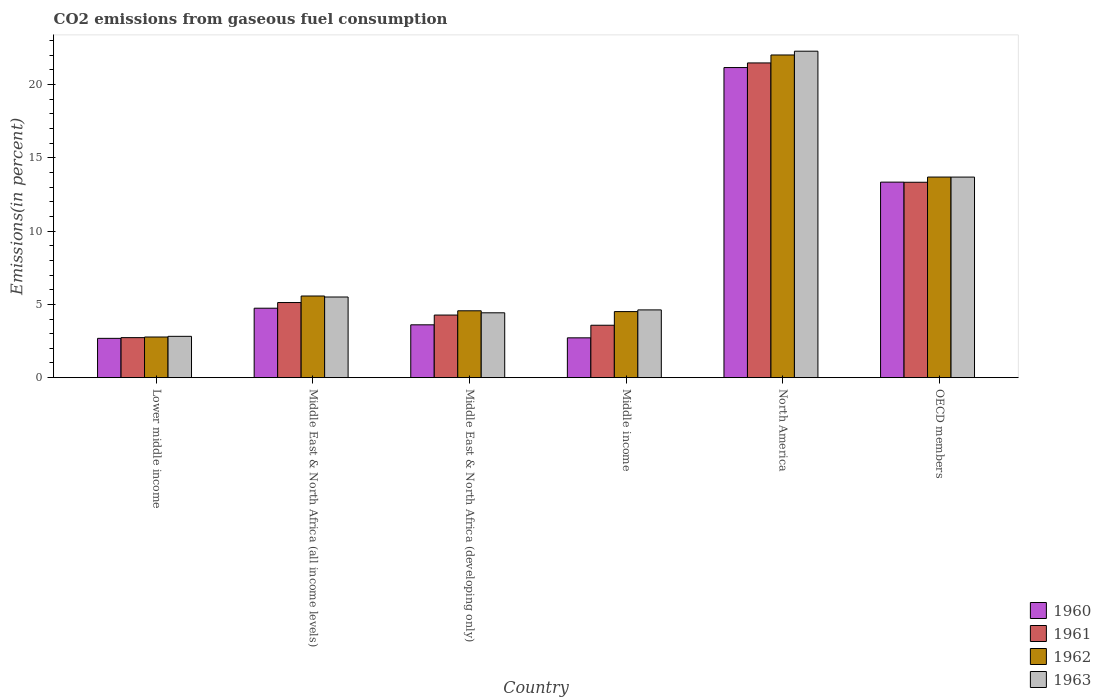How many different coloured bars are there?
Provide a short and direct response. 4. Are the number of bars per tick equal to the number of legend labels?
Your response must be concise. Yes. Are the number of bars on each tick of the X-axis equal?
Give a very brief answer. Yes. How many bars are there on the 5th tick from the left?
Your response must be concise. 4. How many bars are there on the 1st tick from the right?
Keep it short and to the point. 4. What is the total CO2 emitted in 1960 in Middle income?
Provide a succinct answer. 2.72. Across all countries, what is the maximum total CO2 emitted in 1963?
Ensure brevity in your answer.  22.26. Across all countries, what is the minimum total CO2 emitted in 1962?
Provide a short and direct response. 2.77. In which country was the total CO2 emitted in 1963 maximum?
Your response must be concise. North America. In which country was the total CO2 emitted in 1962 minimum?
Your answer should be compact. Lower middle income. What is the total total CO2 emitted in 1961 in the graph?
Keep it short and to the point. 50.48. What is the difference between the total CO2 emitted in 1963 in Middle East & North Africa (developing only) and that in Middle income?
Offer a very short reply. -0.2. What is the difference between the total CO2 emitted in 1961 in Middle East & North Africa (all income levels) and the total CO2 emitted in 1962 in Lower middle income?
Ensure brevity in your answer.  2.35. What is the average total CO2 emitted in 1962 per country?
Your answer should be compact. 8.85. What is the difference between the total CO2 emitted of/in 1960 and total CO2 emitted of/in 1961 in Middle income?
Your answer should be compact. -0.86. What is the ratio of the total CO2 emitted in 1960 in Middle East & North Africa (all income levels) to that in OECD members?
Give a very brief answer. 0.36. What is the difference between the highest and the second highest total CO2 emitted in 1960?
Your answer should be very brief. 8.6. What is the difference between the highest and the lowest total CO2 emitted in 1961?
Ensure brevity in your answer.  18.73. Is it the case that in every country, the sum of the total CO2 emitted in 1962 and total CO2 emitted in 1960 is greater than the total CO2 emitted in 1963?
Your response must be concise. Yes. Are all the bars in the graph horizontal?
Give a very brief answer. No. How many countries are there in the graph?
Keep it short and to the point. 6. Where does the legend appear in the graph?
Provide a succinct answer. Bottom right. How many legend labels are there?
Provide a short and direct response. 4. What is the title of the graph?
Your response must be concise. CO2 emissions from gaseous fuel consumption. What is the label or title of the Y-axis?
Make the answer very short. Emissions(in percent). What is the Emissions(in percent) of 1960 in Lower middle income?
Offer a very short reply. 2.68. What is the Emissions(in percent) in 1961 in Lower middle income?
Your answer should be compact. 2.73. What is the Emissions(in percent) in 1962 in Lower middle income?
Ensure brevity in your answer.  2.77. What is the Emissions(in percent) of 1963 in Lower middle income?
Offer a very short reply. 2.82. What is the Emissions(in percent) in 1960 in Middle East & North Africa (all income levels)?
Offer a very short reply. 4.74. What is the Emissions(in percent) in 1961 in Middle East & North Africa (all income levels)?
Provide a succinct answer. 5.12. What is the Emissions(in percent) of 1962 in Middle East & North Africa (all income levels)?
Your response must be concise. 5.57. What is the Emissions(in percent) in 1963 in Middle East & North Africa (all income levels)?
Offer a terse response. 5.5. What is the Emissions(in percent) in 1960 in Middle East & North Africa (developing only)?
Offer a very short reply. 3.6. What is the Emissions(in percent) in 1961 in Middle East & North Africa (developing only)?
Offer a terse response. 4.27. What is the Emissions(in percent) in 1962 in Middle East & North Africa (developing only)?
Offer a very short reply. 4.56. What is the Emissions(in percent) in 1963 in Middle East & North Africa (developing only)?
Offer a very short reply. 4.42. What is the Emissions(in percent) of 1960 in Middle income?
Provide a short and direct response. 2.72. What is the Emissions(in percent) of 1961 in Middle income?
Give a very brief answer. 3.57. What is the Emissions(in percent) in 1962 in Middle income?
Your response must be concise. 4.5. What is the Emissions(in percent) of 1963 in Middle income?
Offer a very short reply. 4.62. What is the Emissions(in percent) of 1960 in North America?
Give a very brief answer. 21.15. What is the Emissions(in percent) of 1961 in North America?
Your answer should be very brief. 21.46. What is the Emissions(in percent) of 1962 in North America?
Offer a very short reply. 22. What is the Emissions(in percent) of 1963 in North America?
Give a very brief answer. 22.26. What is the Emissions(in percent) of 1960 in OECD members?
Give a very brief answer. 13.33. What is the Emissions(in percent) in 1961 in OECD members?
Give a very brief answer. 13.33. What is the Emissions(in percent) in 1962 in OECD members?
Make the answer very short. 13.68. What is the Emissions(in percent) in 1963 in OECD members?
Your answer should be compact. 13.68. Across all countries, what is the maximum Emissions(in percent) of 1960?
Your answer should be very brief. 21.15. Across all countries, what is the maximum Emissions(in percent) of 1961?
Ensure brevity in your answer.  21.46. Across all countries, what is the maximum Emissions(in percent) of 1962?
Ensure brevity in your answer.  22. Across all countries, what is the maximum Emissions(in percent) in 1963?
Provide a succinct answer. 22.26. Across all countries, what is the minimum Emissions(in percent) of 1960?
Ensure brevity in your answer.  2.68. Across all countries, what is the minimum Emissions(in percent) in 1961?
Offer a very short reply. 2.73. Across all countries, what is the minimum Emissions(in percent) in 1962?
Provide a short and direct response. 2.77. Across all countries, what is the minimum Emissions(in percent) of 1963?
Make the answer very short. 2.82. What is the total Emissions(in percent) of 1960 in the graph?
Ensure brevity in your answer.  48.22. What is the total Emissions(in percent) in 1961 in the graph?
Give a very brief answer. 50.48. What is the total Emissions(in percent) of 1962 in the graph?
Give a very brief answer. 53.09. What is the total Emissions(in percent) in 1963 in the graph?
Keep it short and to the point. 53.3. What is the difference between the Emissions(in percent) in 1960 in Lower middle income and that in Middle East & North Africa (all income levels)?
Keep it short and to the point. -2.06. What is the difference between the Emissions(in percent) of 1961 in Lower middle income and that in Middle East & North Africa (all income levels)?
Offer a terse response. -2.39. What is the difference between the Emissions(in percent) in 1962 in Lower middle income and that in Middle East & North Africa (all income levels)?
Offer a terse response. -2.8. What is the difference between the Emissions(in percent) of 1963 in Lower middle income and that in Middle East & North Africa (all income levels)?
Make the answer very short. -2.68. What is the difference between the Emissions(in percent) of 1960 in Lower middle income and that in Middle East & North Africa (developing only)?
Make the answer very short. -0.92. What is the difference between the Emissions(in percent) of 1961 in Lower middle income and that in Middle East & North Africa (developing only)?
Make the answer very short. -1.54. What is the difference between the Emissions(in percent) of 1962 in Lower middle income and that in Middle East & North Africa (developing only)?
Provide a short and direct response. -1.79. What is the difference between the Emissions(in percent) in 1963 in Lower middle income and that in Middle East & North Africa (developing only)?
Give a very brief answer. -1.6. What is the difference between the Emissions(in percent) in 1960 in Lower middle income and that in Middle income?
Provide a short and direct response. -0.03. What is the difference between the Emissions(in percent) in 1961 in Lower middle income and that in Middle income?
Provide a short and direct response. -0.84. What is the difference between the Emissions(in percent) of 1962 in Lower middle income and that in Middle income?
Provide a short and direct response. -1.73. What is the difference between the Emissions(in percent) of 1963 in Lower middle income and that in Middle income?
Provide a succinct answer. -1.8. What is the difference between the Emissions(in percent) of 1960 in Lower middle income and that in North America?
Make the answer very short. -18.47. What is the difference between the Emissions(in percent) of 1961 in Lower middle income and that in North America?
Ensure brevity in your answer.  -18.73. What is the difference between the Emissions(in percent) of 1962 in Lower middle income and that in North America?
Offer a terse response. -19.23. What is the difference between the Emissions(in percent) of 1963 in Lower middle income and that in North America?
Provide a succinct answer. -19.44. What is the difference between the Emissions(in percent) in 1960 in Lower middle income and that in OECD members?
Your answer should be compact. -10.65. What is the difference between the Emissions(in percent) of 1961 in Lower middle income and that in OECD members?
Ensure brevity in your answer.  -10.6. What is the difference between the Emissions(in percent) of 1962 in Lower middle income and that in OECD members?
Offer a very short reply. -10.91. What is the difference between the Emissions(in percent) in 1963 in Lower middle income and that in OECD members?
Offer a terse response. -10.86. What is the difference between the Emissions(in percent) of 1960 in Middle East & North Africa (all income levels) and that in Middle East & North Africa (developing only)?
Provide a short and direct response. 1.13. What is the difference between the Emissions(in percent) in 1961 in Middle East & North Africa (all income levels) and that in Middle East & North Africa (developing only)?
Your answer should be compact. 0.85. What is the difference between the Emissions(in percent) in 1962 in Middle East & North Africa (all income levels) and that in Middle East & North Africa (developing only)?
Your answer should be compact. 1.01. What is the difference between the Emissions(in percent) of 1963 in Middle East & North Africa (all income levels) and that in Middle East & North Africa (developing only)?
Ensure brevity in your answer.  1.08. What is the difference between the Emissions(in percent) of 1960 in Middle East & North Africa (all income levels) and that in Middle income?
Offer a terse response. 2.02. What is the difference between the Emissions(in percent) of 1961 in Middle East & North Africa (all income levels) and that in Middle income?
Your response must be concise. 1.55. What is the difference between the Emissions(in percent) in 1962 in Middle East & North Africa (all income levels) and that in Middle income?
Provide a short and direct response. 1.06. What is the difference between the Emissions(in percent) of 1963 in Middle East & North Africa (all income levels) and that in Middle income?
Keep it short and to the point. 0.88. What is the difference between the Emissions(in percent) of 1960 in Middle East & North Africa (all income levels) and that in North America?
Offer a terse response. -16.41. What is the difference between the Emissions(in percent) in 1961 in Middle East & North Africa (all income levels) and that in North America?
Your response must be concise. -16.34. What is the difference between the Emissions(in percent) of 1962 in Middle East & North Africa (all income levels) and that in North America?
Offer a very short reply. -16.44. What is the difference between the Emissions(in percent) in 1963 in Middle East & North Africa (all income levels) and that in North America?
Make the answer very short. -16.76. What is the difference between the Emissions(in percent) in 1960 in Middle East & North Africa (all income levels) and that in OECD members?
Make the answer very short. -8.6. What is the difference between the Emissions(in percent) in 1961 in Middle East & North Africa (all income levels) and that in OECD members?
Give a very brief answer. -8.2. What is the difference between the Emissions(in percent) of 1962 in Middle East & North Africa (all income levels) and that in OECD members?
Keep it short and to the point. -8.11. What is the difference between the Emissions(in percent) in 1963 in Middle East & North Africa (all income levels) and that in OECD members?
Make the answer very short. -8.18. What is the difference between the Emissions(in percent) in 1960 in Middle East & North Africa (developing only) and that in Middle income?
Your answer should be very brief. 0.89. What is the difference between the Emissions(in percent) in 1961 in Middle East & North Africa (developing only) and that in Middle income?
Your response must be concise. 0.7. What is the difference between the Emissions(in percent) of 1962 in Middle East & North Africa (developing only) and that in Middle income?
Keep it short and to the point. 0.06. What is the difference between the Emissions(in percent) of 1963 in Middle East & North Africa (developing only) and that in Middle income?
Offer a terse response. -0.2. What is the difference between the Emissions(in percent) of 1960 in Middle East & North Africa (developing only) and that in North America?
Your answer should be very brief. -17.54. What is the difference between the Emissions(in percent) of 1961 in Middle East & North Africa (developing only) and that in North America?
Your response must be concise. -17.19. What is the difference between the Emissions(in percent) in 1962 in Middle East & North Africa (developing only) and that in North America?
Your answer should be very brief. -17.44. What is the difference between the Emissions(in percent) of 1963 in Middle East & North Africa (developing only) and that in North America?
Give a very brief answer. -17.84. What is the difference between the Emissions(in percent) of 1960 in Middle East & North Africa (developing only) and that in OECD members?
Provide a succinct answer. -9.73. What is the difference between the Emissions(in percent) in 1961 in Middle East & North Africa (developing only) and that in OECD members?
Provide a short and direct response. -9.06. What is the difference between the Emissions(in percent) of 1962 in Middle East & North Africa (developing only) and that in OECD members?
Provide a succinct answer. -9.12. What is the difference between the Emissions(in percent) in 1963 in Middle East & North Africa (developing only) and that in OECD members?
Offer a very short reply. -9.25. What is the difference between the Emissions(in percent) of 1960 in Middle income and that in North America?
Your answer should be very brief. -18.43. What is the difference between the Emissions(in percent) in 1961 in Middle income and that in North America?
Offer a terse response. -17.89. What is the difference between the Emissions(in percent) in 1962 in Middle income and that in North America?
Make the answer very short. -17.5. What is the difference between the Emissions(in percent) in 1963 in Middle income and that in North America?
Provide a succinct answer. -17.64. What is the difference between the Emissions(in percent) of 1960 in Middle income and that in OECD members?
Your answer should be compact. -10.62. What is the difference between the Emissions(in percent) in 1961 in Middle income and that in OECD members?
Provide a short and direct response. -9.75. What is the difference between the Emissions(in percent) of 1962 in Middle income and that in OECD members?
Offer a terse response. -9.17. What is the difference between the Emissions(in percent) in 1963 in Middle income and that in OECD members?
Make the answer very short. -9.06. What is the difference between the Emissions(in percent) in 1960 in North America and that in OECD members?
Offer a terse response. 7.81. What is the difference between the Emissions(in percent) of 1961 in North America and that in OECD members?
Your answer should be very brief. 8.14. What is the difference between the Emissions(in percent) in 1962 in North America and that in OECD members?
Your answer should be compact. 8.32. What is the difference between the Emissions(in percent) of 1963 in North America and that in OECD members?
Provide a short and direct response. 8.58. What is the difference between the Emissions(in percent) of 1960 in Lower middle income and the Emissions(in percent) of 1961 in Middle East & North Africa (all income levels)?
Provide a succinct answer. -2.44. What is the difference between the Emissions(in percent) of 1960 in Lower middle income and the Emissions(in percent) of 1962 in Middle East & North Africa (all income levels)?
Make the answer very short. -2.89. What is the difference between the Emissions(in percent) of 1960 in Lower middle income and the Emissions(in percent) of 1963 in Middle East & North Africa (all income levels)?
Keep it short and to the point. -2.82. What is the difference between the Emissions(in percent) of 1961 in Lower middle income and the Emissions(in percent) of 1962 in Middle East & North Africa (all income levels)?
Ensure brevity in your answer.  -2.84. What is the difference between the Emissions(in percent) in 1961 in Lower middle income and the Emissions(in percent) in 1963 in Middle East & North Africa (all income levels)?
Offer a very short reply. -2.77. What is the difference between the Emissions(in percent) in 1962 in Lower middle income and the Emissions(in percent) in 1963 in Middle East & North Africa (all income levels)?
Make the answer very short. -2.73. What is the difference between the Emissions(in percent) of 1960 in Lower middle income and the Emissions(in percent) of 1961 in Middle East & North Africa (developing only)?
Your answer should be compact. -1.59. What is the difference between the Emissions(in percent) of 1960 in Lower middle income and the Emissions(in percent) of 1962 in Middle East & North Africa (developing only)?
Provide a succinct answer. -1.88. What is the difference between the Emissions(in percent) in 1960 in Lower middle income and the Emissions(in percent) in 1963 in Middle East & North Africa (developing only)?
Offer a very short reply. -1.74. What is the difference between the Emissions(in percent) of 1961 in Lower middle income and the Emissions(in percent) of 1962 in Middle East & North Africa (developing only)?
Keep it short and to the point. -1.83. What is the difference between the Emissions(in percent) of 1961 in Lower middle income and the Emissions(in percent) of 1963 in Middle East & North Africa (developing only)?
Keep it short and to the point. -1.69. What is the difference between the Emissions(in percent) in 1962 in Lower middle income and the Emissions(in percent) in 1963 in Middle East & North Africa (developing only)?
Give a very brief answer. -1.65. What is the difference between the Emissions(in percent) of 1960 in Lower middle income and the Emissions(in percent) of 1961 in Middle income?
Offer a terse response. -0.89. What is the difference between the Emissions(in percent) in 1960 in Lower middle income and the Emissions(in percent) in 1962 in Middle income?
Offer a terse response. -1.82. What is the difference between the Emissions(in percent) of 1960 in Lower middle income and the Emissions(in percent) of 1963 in Middle income?
Offer a terse response. -1.94. What is the difference between the Emissions(in percent) of 1961 in Lower middle income and the Emissions(in percent) of 1962 in Middle income?
Offer a very short reply. -1.78. What is the difference between the Emissions(in percent) in 1961 in Lower middle income and the Emissions(in percent) in 1963 in Middle income?
Provide a succinct answer. -1.89. What is the difference between the Emissions(in percent) in 1962 in Lower middle income and the Emissions(in percent) in 1963 in Middle income?
Your response must be concise. -1.85. What is the difference between the Emissions(in percent) of 1960 in Lower middle income and the Emissions(in percent) of 1961 in North America?
Make the answer very short. -18.78. What is the difference between the Emissions(in percent) in 1960 in Lower middle income and the Emissions(in percent) in 1962 in North America?
Make the answer very short. -19.32. What is the difference between the Emissions(in percent) in 1960 in Lower middle income and the Emissions(in percent) in 1963 in North America?
Provide a succinct answer. -19.58. What is the difference between the Emissions(in percent) of 1961 in Lower middle income and the Emissions(in percent) of 1962 in North America?
Provide a short and direct response. -19.27. What is the difference between the Emissions(in percent) of 1961 in Lower middle income and the Emissions(in percent) of 1963 in North America?
Your response must be concise. -19.53. What is the difference between the Emissions(in percent) of 1962 in Lower middle income and the Emissions(in percent) of 1963 in North America?
Give a very brief answer. -19.49. What is the difference between the Emissions(in percent) of 1960 in Lower middle income and the Emissions(in percent) of 1961 in OECD members?
Make the answer very short. -10.64. What is the difference between the Emissions(in percent) of 1960 in Lower middle income and the Emissions(in percent) of 1962 in OECD members?
Provide a succinct answer. -11. What is the difference between the Emissions(in percent) of 1960 in Lower middle income and the Emissions(in percent) of 1963 in OECD members?
Give a very brief answer. -11. What is the difference between the Emissions(in percent) of 1961 in Lower middle income and the Emissions(in percent) of 1962 in OECD members?
Provide a short and direct response. -10.95. What is the difference between the Emissions(in percent) of 1961 in Lower middle income and the Emissions(in percent) of 1963 in OECD members?
Ensure brevity in your answer.  -10.95. What is the difference between the Emissions(in percent) in 1962 in Lower middle income and the Emissions(in percent) in 1963 in OECD members?
Provide a succinct answer. -10.91. What is the difference between the Emissions(in percent) of 1960 in Middle East & North Africa (all income levels) and the Emissions(in percent) of 1961 in Middle East & North Africa (developing only)?
Your answer should be very brief. 0.47. What is the difference between the Emissions(in percent) of 1960 in Middle East & North Africa (all income levels) and the Emissions(in percent) of 1962 in Middle East & North Africa (developing only)?
Your answer should be compact. 0.18. What is the difference between the Emissions(in percent) of 1960 in Middle East & North Africa (all income levels) and the Emissions(in percent) of 1963 in Middle East & North Africa (developing only)?
Make the answer very short. 0.31. What is the difference between the Emissions(in percent) of 1961 in Middle East & North Africa (all income levels) and the Emissions(in percent) of 1962 in Middle East & North Africa (developing only)?
Offer a very short reply. 0.56. What is the difference between the Emissions(in percent) of 1961 in Middle East & North Africa (all income levels) and the Emissions(in percent) of 1963 in Middle East & North Africa (developing only)?
Make the answer very short. 0.7. What is the difference between the Emissions(in percent) of 1962 in Middle East & North Africa (all income levels) and the Emissions(in percent) of 1963 in Middle East & North Africa (developing only)?
Provide a succinct answer. 1.15. What is the difference between the Emissions(in percent) of 1960 in Middle East & North Africa (all income levels) and the Emissions(in percent) of 1961 in Middle income?
Your answer should be very brief. 1.16. What is the difference between the Emissions(in percent) in 1960 in Middle East & North Africa (all income levels) and the Emissions(in percent) in 1962 in Middle income?
Ensure brevity in your answer.  0.23. What is the difference between the Emissions(in percent) of 1960 in Middle East & North Africa (all income levels) and the Emissions(in percent) of 1963 in Middle income?
Your response must be concise. 0.12. What is the difference between the Emissions(in percent) of 1961 in Middle East & North Africa (all income levels) and the Emissions(in percent) of 1962 in Middle income?
Provide a succinct answer. 0.62. What is the difference between the Emissions(in percent) of 1961 in Middle East & North Africa (all income levels) and the Emissions(in percent) of 1963 in Middle income?
Your answer should be very brief. 0.5. What is the difference between the Emissions(in percent) of 1962 in Middle East & North Africa (all income levels) and the Emissions(in percent) of 1963 in Middle income?
Provide a short and direct response. 0.95. What is the difference between the Emissions(in percent) of 1960 in Middle East & North Africa (all income levels) and the Emissions(in percent) of 1961 in North America?
Provide a succinct answer. -16.73. What is the difference between the Emissions(in percent) of 1960 in Middle East & North Africa (all income levels) and the Emissions(in percent) of 1962 in North America?
Ensure brevity in your answer.  -17.27. What is the difference between the Emissions(in percent) of 1960 in Middle East & North Africa (all income levels) and the Emissions(in percent) of 1963 in North America?
Ensure brevity in your answer.  -17.53. What is the difference between the Emissions(in percent) in 1961 in Middle East & North Africa (all income levels) and the Emissions(in percent) in 1962 in North America?
Your answer should be very brief. -16.88. What is the difference between the Emissions(in percent) of 1961 in Middle East & North Africa (all income levels) and the Emissions(in percent) of 1963 in North America?
Give a very brief answer. -17.14. What is the difference between the Emissions(in percent) of 1962 in Middle East & North Africa (all income levels) and the Emissions(in percent) of 1963 in North America?
Give a very brief answer. -16.69. What is the difference between the Emissions(in percent) in 1960 in Middle East & North Africa (all income levels) and the Emissions(in percent) in 1961 in OECD members?
Ensure brevity in your answer.  -8.59. What is the difference between the Emissions(in percent) in 1960 in Middle East & North Africa (all income levels) and the Emissions(in percent) in 1962 in OECD members?
Make the answer very short. -8.94. What is the difference between the Emissions(in percent) in 1960 in Middle East & North Africa (all income levels) and the Emissions(in percent) in 1963 in OECD members?
Your response must be concise. -8.94. What is the difference between the Emissions(in percent) of 1961 in Middle East & North Africa (all income levels) and the Emissions(in percent) of 1962 in OECD members?
Provide a short and direct response. -8.56. What is the difference between the Emissions(in percent) of 1961 in Middle East & North Africa (all income levels) and the Emissions(in percent) of 1963 in OECD members?
Offer a terse response. -8.55. What is the difference between the Emissions(in percent) in 1962 in Middle East & North Africa (all income levels) and the Emissions(in percent) in 1963 in OECD members?
Make the answer very short. -8.11. What is the difference between the Emissions(in percent) of 1960 in Middle East & North Africa (developing only) and the Emissions(in percent) of 1961 in Middle income?
Your response must be concise. 0.03. What is the difference between the Emissions(in percent) of 1960 in Middle East & North Africa (developing only) and the Emissions(in percent) of 1962 in Middle income?
Your answer should be compact. -0.9. What is the difference between the Emissions(in percent) in 1960 in Middle East & North Africa (developing only) and the Emissions(in percent) in 1963 in Middle income?
Offer a terse response. -1.02. What is the difference between the Emissions(in percent) in 1961 in Middle East & North Africa (developing only) and the Emissions(in percent) in 1962 in Middle income?
Offer a very short reply. -0.24. What is the difference between the Emissions(in percent) of 1961 in Middle East & North Africa (developing only) and the Emissions(in percent) of 1963 in Middle income?
Keep it short and to the point. -0.35. What is the difference between the Emissions(in percent) of 1962 in Middle East & North Africa (developing only) and the Emissions(in percent) of 1963 in Middle income?
Make the answer very short. -0.06. What is the difference between the Emissions(in percent) in 1960 in Middle East & North Africa (developing only) and the Emissions(in percent) in 1961 in North America?
Keep it short and to the point. -17.86. What is the difference between the Emissions(in percent) of 1960 in Middle East & North Africa (developing only) and the Emissions(in percent) of 1962 in North America?
Your answer should be compact. -18.4. What is the difference between the Emissions(in percent) in 1960 in Middle East & North Africa (developing only) and the Emissions(in percent) in 1963 in North America?
Provide a succinct answer. -18.66. What is the difference between the Emissions(in percent) in 1961 in Middle East & North Africa (developing only) and the Emissions(in percent) in 1962 in North America?
Make the answer very short. -17.73. What is the difference between the Emissions(in percent) of 1961 in Middle East & North Africa (developing only) and the Emissions(in percent) of 1963 in North America?
Your response must be concise. -17.99. What is the difference between the Emissions(in percent) of 1962 in Middle East & North Africa (developing only) and the Emissions(in percent) of 1963 in North America?
Provide a short and direct response. -17.7. What is the difference between the Emissions(in percent) in 1960 in Middle East & North Africa (developing only) and the Emissions(in percent) in 1961 in OECD members?
Ensure brevity in your answer.  -9.72. What is the difference between the Emissions(in percent) of 1960 in Middle East & North Africa (developing only) and the Emissions(in percent) of 1962 in OECD members?
Provide a short and direct response. -10.08. What is the difference between the Emissions(in percent) of 1960 in Middle East & North Africa (developing only) and the Emissions(in percent) of 1963 in OECD members?
Keep it short and to the point. -10.07. What is the difference between the Emissions(in percent) of 1961 in Middle East & North Africa (developing only) and the Emissions(in percent) of 1962 in OECD members?
Provide a short and direct response. -9.41. What is the difference between the Emissions(in percent) of 1961 in Middle East & North Africa (developing only) and the Emissions(in percent) of 1963 in OECD members?
Provide a succinct answer. -9.41. What is the difference between the Emissions(in percent) of 1962 in Middle East & North Africa (developing only) and the Emissions(in percent) of 1963 in OECD members?
Keep it short and to the point. -9.12. What is the difference between the Emissions(in percent) in 1960 in Middle income and the Emissions(in percent) in 1961 in North America?
Keep it short and to the point. -18.75. What is the difference between the Emissions(in percent) of 1960 in Middle income and the Emissions(in percent) of 1962 in North America?
Ensure brevity in your answer.  -19.29. What is the difference between the Emissions(in percent) in 1960 in Middle income and the Emissions(in percent) in 1963 in North America?
Offer a very short reply. -19.55. What is the difference between the Emissions(in percent) of 1961 in Middle income and the Emissions(in percent) of 1962 in North America?
Keep it short and to the point. -18.43. What is the difference between the Emissions(in percent) in 1961 in Middle income and the Emissions(in percent) in 1963 in North America?
Provide a short and direct response. -18.69. What is the difference between the Emissions(in percent) in 1962 in Middle income and the Emissions(in percent) in 1963 in North America?
Your answer should be very brief. -17.76. What is the difference between the Emissions(in percent) in 1960 in Middle income and the Emissions(in percent) in 1961 in OECD members?
Your response must be concise. -10.61. What is the difference between the Emissions(in percent) of 1960 in Middle income and the Emissions(in percent) of 1962 in OECD members?
Provide a succinct answer. -10.96. What is the difference between the Emissions(in percent) in 1960 in Middle income and the Emissions(in percent) in 1963 in OECD members?
Offer a terse response. -10.96. What is the difference between the Emissions(in percent) of 1961 in Middle income and the Emissions(in percent) of 1962 in OECD members?
Provide a short and direct response. -10.11. What is the difference between the Emissions(in percent) in 1961 in Middle income and the Emissions(in percent) in 1963 in OECD members?
Your answer should be very brief. -10.1. What is the difference between the Emissions(in percent) of 1962 in Middle income and the Emissions(in percent) of 1963 in OECD members?
Offer a very short reply. -9.17. What is the difference between the Emissions(in percent) of 1960 in North America and the Emissions(in percent) of 1961 in OECD members?
Offer a terse response. 7.82. What is the difference between the Emissions(in percent) in 1960 in North America and the Emissions(in percent) in 1962 in OECD members?
Provide a succinct answer. 7.47. What is the difference between the Emissions(in percent) of 1960 in North America and the Emissions(in percent) of 1963 in OECD members?
Ensure brevity in your answer.  7.47. What is the difference between the Emissions(in percent) in 1961 in North America and the Emissions(in percent) in 1962 in OECD members?
Give a very brief answer. 7.78. What is the difference between the Emissions(in percent) in 1961 in North America and the Emissions(in percent) in 1963 in OECD members?
Your answer should be very brief. 7.78. What is the difference between the Emissions(in percent) of 1962 in North America and the Emissions(in percent) of 1963 in OECD members?
Offer a terse response. 8.33. What is the average Emissions(in percent) in 1960 per country?
Give a very brief answer. 8.04. What is the average Emissions(in percent) of 1961 per country?
Provide a succinct answer. 8.41. What is the average Emissions(in percent) of 1962 per country?
Keep it short and to the point. 8.85. What is the average Emissions(in percent) of 1963 per country?
Your answer should be very brief. 8.88. What is the difference between the Emissions(in percent) of 1960 and Emissions(in percent) of 1961 in Lower middle income?
Offer a terse response. -0.05. What is the difference between the Emissions(in percent) of 1960 and Emissions(in percent) of 1962 in Lower middle income?
Your answer should be very brief. -0.09. What is the difference between the Emissions(in percent) of 1960 and Emissions(in percent) of 1963 in Lower middle income?
Provide a short and direct response. -0.14. What is the difference between the Emissions(in percent) of 1961 and Emissions(in percent) of 1962 in Lower middle income?
Offer a very short reply. -0.04. What is the difference between the Emissions(in percent) in 1961 and Emissions(in percent) in 1963 in Lower middle income?
Your answer should be very brief. -0.09. What is the difference between the Emissions(in percent) in 1962 and Emissions(in percent) in 1963 in Lower middle income?
Your answer should be compact. -0.05. What is the difference between the Emissions(in percent) in 1960 and Emissions(in percent) in 1961 in Middle East & North Africa (all income levels)?
Offer a very short reply. -0.39. What is the difference between the Emissions(in percent) in 1960 and Emissions(in percent) in 1962 in Middle East & North Africa (all income levels)?
Make the answer very short. -0.83. What is the difference between the Emissions(in percent) in 1960 and Emissions(in percent) in 1963 in Middle East & North Africa (all income levels)?
Your answer should be very brief. -0.76. What is the difference between the Emissions(in percent) in 1961 and Emissions(in percent) in 1962 in Middle East & North Africa (all income levels)?
Make the answer very short. -0.45. What is the difference between the Emissions(in percent) of 1961 and Emissions(in percent) of 1963 in Middle East & North Africa (all income levels)?
Keep it short and to the point. -0.38. What is the difference between the Emissions(in percent) of 1962 and Emissions(in percent) of 1963 in Middle East & North Africa (all income levels)?
Give a very brief answer. 0.07. What is the difference between the Emissions(in percent) of 1960 and Emissions(in percent) of 1961 in Middle East & North Africa (developing only)?
Keep it short and to the point. -0.67. What is the difference between the Emissions(in percent) in 1960 and Emissions(in percent) in 1962 in Middle East & North Africa (developing only)?
Ensure brevity in your answer.  -0.96. What is the difference between the Emissions(in percent) of 1960 and Emissions(in percent) of 1963 in Middle East & North Africa (developing only)?
Ensure brevity in your answer.  -0.82. What is the difference between the Emissions(in percent) in 1961 and Emissions(in percent) in 1962 in Middle East & North Africa (developing only)?
Provide a succinct answer. -0.29. What is the difference between the Emissions(in percent) in 1961 and Emissions(in percent) in 1963 in Middle East & North Africa (developing only)?
Offer a terse response. -0.15. What is the difference between the Emissions(in percent) in 1962 and Emissions(in percent) in 1963 in Middle East & North Africa (developing only)?
Give a very brief answer. 0.14. What is the difference between the Emissions(in percent) of 1960 and Emissions(in percent) of 1961 in Middle income?
Provide a succinct answer. -0.86. What is the difference between the Emissions(in percent) in 1960 and Emissions(in percent) in 1962 in Middle income?
Your response must be concise. -1.79. What is the difference between the Emissions(in percent) of 1960 and Emissions(in percent) of 1963 in Middle income?
Give a very brief answer. -1.91. What is the difference between the Emissions(in percent) in 1961 and Emissions(in percent) in 1962 in Middle income?
Ensure brevity in your answer.  -0.93. What is the difference between the Emissions(in percent) of 1961 and Emissions(in percent) of 1963 in Middle income?
Provide a short and direct response. -1.05. What is the difference between the Emissions(in percent) in 1962 and Emissions(in percent) in 1963 in Middle income?
Offer a very short reply. -0.12. What is the difference between the Emissions(in percent) of 1960 and Emissions(in percent) of 1961 in North America?
Provide a short and direct response. -0.32. What is the difference between the Emissions(in percent) in 1960 and Emissions(in percent) in 1962 in North America?
Your response must be concise. -0.86. What is the difference between the Emissions(in percent) in 1960 and Emissions(in percent) in 1963 in North America?
Keep it short and to the point. -1.12. What is the difference between the Emissions(in percent) of 1961 and Emissions(in percent) of 1962 in North America?
Your answer should be very brief. -0.54. What is the difference between the Emissions(in percent) of 1962 and Emissions(in percent) of 1963 in North America?
Provide a short and direct response. -0.26. What is the difference between the Emissions(in percent) in 1960 and Emissions(in percent) in 1961 in OECD members?
Provide a succinct answer. 0.01. What is the difference between the Emissions(in percent) of 1960 and Emissions(in percent) of 1962 in OECD members?
Your answer should be very brief. -0.35. What is the difference between the Emissions(in percent) of 1960 and Emissions(in percent) of 1963 in OECD members?
Your answer should be very brief. -0.34. What is the difference between the Emissions(in percent) of 1961 and Emissions(in percent) of 1962 in OECD members?
Make the answer very short. -0.35. What is the difference between the Emissions(in percent) in 1961 and Emissions(in percent) in 1963 in OECD members?
Provide a short and direct response. -0.35. What is the difference between the Emissions(in percent) in 1962 and Emissions(in percent) in 1963 in OECD members?
Your answer should be very brief. 0. What is the ratio of the Emissions(in percent) in 1960 in Lower middle income to that in Middle East & North Africa (all income levels)?
Offer a very short reply. 0.57. What is the ratio of the Emissions(in percent) of 1961 in Lower middle income to that in Middle East & North Africa (all income levels)?
Offer a terse response. 0.53. What is the ratio of the Emissions(in percent) of 1962 in Lower middle income to that in Middle East & North Africa (all income levels)?
Offer a terse response. 0.5. What is the ratio of the Emissions(in percent) in 1963 in Lower middle income to that in Middle East & North Africa (all income levels)?
Provide a short and direct response. 0.51. What is the ratio of the Emissions(in percent) of 1960 in Lower middle income to that in Middle East & North Africa (developing only)?
Offer a very short reply. 0.74. What is the ratio of the Emissions(in percent) of 1961 in Lower middle income to that in Middle East & North Africa (developing only)?
Offer a very short reply. 0.64. What is the ratio of the Emissions(in percent) of 1962 in Lower middle income to that in Middle East & North Africa (developing only)?
Your answer should be compact. 0.61. What is the ratio of the Emissions(in percent) of 1963 in Lower middle income to that in Middle East & North Africa (developing only)?
Make the answer very short. 0.64. What is the ratio of the Emissions(in percent) in 1960 in Lower middle income to that in Middle income?
Give a very brief answer. 0.99. What is the ratio of the Emissions(in percent) in 1961 in Lower middle income to that in Middle income?
Ensure brevity in your answer.  0.76. What is the ratio of the Emissions(in percent) in 1962 in Lower middle income to that in Middle income?
Provide a short and direct response. 0.62. What is the ratio of the Emissions(in percent) of 1963 in Lower middle income to that in Middle income?
Provide a short and direct response. 0.61. What is the ratio of the Emissions(in percent) of 1960 in Lower middle income to that in North America?
Keep it short and to the point. 0.13. What is the ratio of the Emissions(in percent) of 1961 in Lower middle income to that in North America?
Offer a terse response. 0.13. What is the ratio of the Emissions(in percent) of 1962 in Lower middle income to that in North America?
Provide a short and direct response. 0.13. What is the ratio of the Emissions(in percent) of 1963 in Lower middle income to that in North America?
Give a very brief answer. 0.13. What is the ratio of the Emissions(in percent) of 1960 in Lower middle income to that in OECD members?
Your answer should be compact. 0.2. What is the ratio of the Emissions(in percent) of 1961 in Lower middle income to that in OECD members?
Give a very brief answer. 0.2. What is the ratio of the Emissions(in percent) of 1962 in Lower middle income to that in OECD members?
Offer a terse response. 0.2. What is the ratio of the Emissions(in percent) in 1963 in Lower middle income to that in OECD members?
Your answer should be very brief. 0.21. What is the ratio of the Emissions(in percent) of 1960 in Middle East & North Africa (all income levels) to that in Middle East & North Africa (developing only)?
Keep it short and to the point. 1.31. What is the ratio of the Emissions(in percent) in 1961 in Middle East & North Africa (all income levels) to that in Middle East & North Africa (developing only)?
Offer a terse response. 1.2. What is the ratio of the Emissions(in percent) in 1962 in Middle East & North Africa (all income levels) to that in Middle East & North Africa (developing only)?
Your response must be concise. 1.22. What is the ratio of the Emissions(in percent) of 1963 in Middle East & North Africa (all income levels) to that in Middle East & North Africa (developing only)?
Make the answer very short. 1.24. What is the ratio of the Emissions(in percent) in 1960 in Middle East & North Africa (all income levels) to that in Middle income?
Give a very brief answer. 1.74. What is the ratio of the Emissions(in percent) of 1961 in Middle East & North Africa (all income levels) to that in Middle income?
Make the answer very short. 1.43. What is the ratio of the Emissions(in percent) of 1962 in Middle East & North Africa (all income levels) to that in Middle income?
Offer a very short reply. 1.24. What is the ratio of the Emissions(in percent) of 1963 in Middle East & North Africa (all income levels) to that in Middle income?
Give a very brief answer. 1.19. What is the ratio of the Emissions(in percent) in 1960 in Middle East & North Africa (all income levels) to that in North America?
Offer a terse response. 0.22. What is the ratio of the Emissions(in percent) of 1961 in Middle East & North Africa (all income levels) to that in North America?
Provide a succinct answer. 0.24. What is the ratio of the Emissions(in percent) of 1962 in Middle East & North Africa (all income levels) to that in North America?
Your answer should be very brief. 0.25. What is the ratio of the Emissions(in percent) in 1963 in Middle East & North Africa (all income levels) to that in North America?
Keep it short and to the point. 0.25. What is the ratio of the Emissions(in percent) of 1960 in Middle East & North Africa (all income levels) to that in OECD members?
Provide a succinct answer. 0.36. What is the ratio of the Emissions(in percent) of 1961 in Middle East & North Africa (all income levels) to that in OECD members?
Keep it short and to the point. 0.38. What is the ratio of the Emissions(in percent) of 1962 in Middle East & North Africa (all income levels) to that in OECD members?
Your response must be concise. 0.41. What is the ratio of the Emissions(in percent) in 1963 in Middle East & North Africa (all income levels) to that in OECD members?
Offer a terse response. 0.4. What is the ratio of the Emissions(in percent) in 1960 in Middle East & North Africa (developing only) to that in Middle income?
Give a very brief answer. 1.33. What is the ratio of the Emissions(in percent) of 1961 in Middle East & North Africa (developing only) to that in Middle income?
Your answer should be very brief. 1.19. What is the ratio of the Emissions(in percent) of 1962 in Middle East & North Africa (developing only) to that in Middle income?
Your answer should be compact. 1.01. What is the ratio of the Emissions(in percent) of 1963 in Middle East & North Africa (developing only) to that in Middle income?
Make the answer very short. 0.96. What is the ratio of the Emissions(in percent) in 1960 in Middle East & North Africa (developing only) to that in North America?
Offer a terse response. 0.17. What is the ratio of the Emissions(in percent) of 1961 in Middle East & North Africa (developing only) to that in North America?
Offer a very short reply. 0.2. What is the ratio of the Emissions(in percent) of 1962 in Middle East & North Africa (developing only) to that in North America?
Your answer should be very brief. 0.21. What is the ratio of the Emissions(in percent) in 1963 in Middle East & North Africa (developing only) to that in North America?
Provide a short and direct response. 0.2. What is the ratio of the Emissions(in percent) of 1960 in Middle East & North Africa (developing only) to that in OECD members?
Offer a terse response. 0.27. What is the ratio of the Emissions(in percent) in 1961 in Middle East & North Africa (developing only) to that in OECD members?
Provide a succinct answer. 0.32. What is the ratio of the Emissions(in percent) in 1962 in Middle East & North Africa (developing only) to that in OECD members?
Offer a terse response. 0.33. What is the ratio of the Emissions(in percent) in 1963 in Middle East & North Africa (developing only) to that in OECD members?
Your answer should be compact. 0.32. What is the ratio of the Emissions(in percent) of 1960 in Middle income to that in North America?
Give a very brief answer. 0.13. What is the ratio of the Emissions(in percent) of 1961 in Middle income to that in North America?
Ensure brevity in your answer.  0.17. What is the ratio of the Emissions(in percent) of 1962 in Middle income to that in North America?
Ensure brevity in your answer.  0.2. What is the ratio of the Emissions(in percent) in 1963 in Middle income to that in North America?
Provide a short and direct response. 0.21. What is the ratio of the Emissions(in percent) of 1960 in Middle income to that in OECD members?
Keep it short and to the point. 0.2. What is the ratio of the Emissions(in percent) in 1961 in Middle income to that in OECD members?
Provide a short and direct response. 0.27. What is the ratio of the Emissions(in percent) in 1962 in Middle income to that in OECD members?
Your answer should be compact. 0.33. What is the ratio of the Emissions(in percent) of 1963 in Middle income to that in OECD members?
Your answer should be compact. 0.34. What is the ratio of the Emissions(in percent) in 1960 in North America to that in OECD members?
Keep it short and to the point. 1.59. What is the ratio of the Emissions(in percent) in 1961 in North America to that in OECD members?
Your answer should be compact. 1.61. What is the ratio of the Emissions(in percent) of 1962 in North America to that in OECD members?
Provide a short and direct response. 1.61. What is the ratio of the Emissions(in percent) of 1963 in North America to that in OECD members?
Give a very brief answer. 1.63. What is the difference between the highest and the second highest Emissions(in percent) of 1960?
Ensure brevity in your answer.  7.81. What is the difference between the highest and the second highest Emissions(in percent) of 1961?
Provide a short and direct response. 8.14. What is the difference between the highest and the second highest Emissions(in percent) of 1962?
Offer a very short reply. 8.32. What is the difference between the highest and the second highest Emissions(in percent) of 1963?
Ensure brevity in your answer.  8.58. What is the difference between the highest and the lowest Emissions(in percent) in 1960?
Provide a short and direct response. 18.47. What is the difference between the highest and the lowest Emissions(in percent) in 1961?
Provide a short and direct response. 18.73. What is the difference between the highest and the lowest Emissions(in percent) in 1962?
Keep it short and to the point. 19.23. What is the difference between the highest and the lowest Emissions(in percent) in 1963?
Provide a short and direct response. 19.44. 